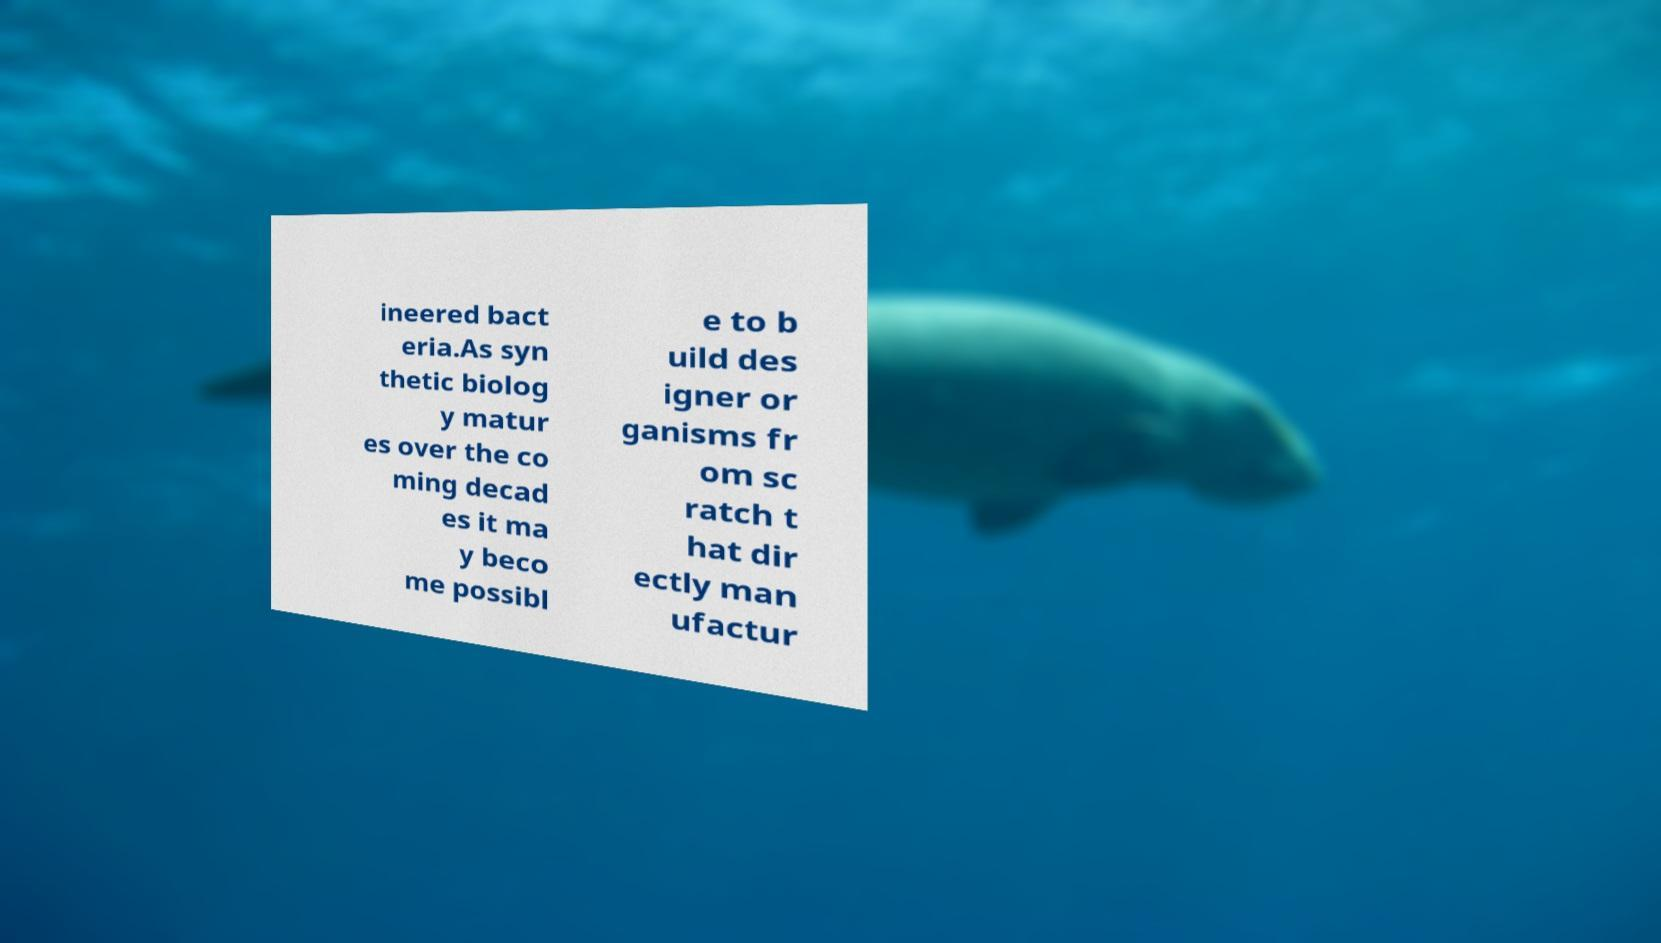Please identify and transcribe the text found in this image. ineered bact eria.As syn thetic biolog y matur es over the co ming decad es it ma y beco me possibl e to b uild des igner or ganisms fr om sc ratch t hat dir ectly man ufactur 